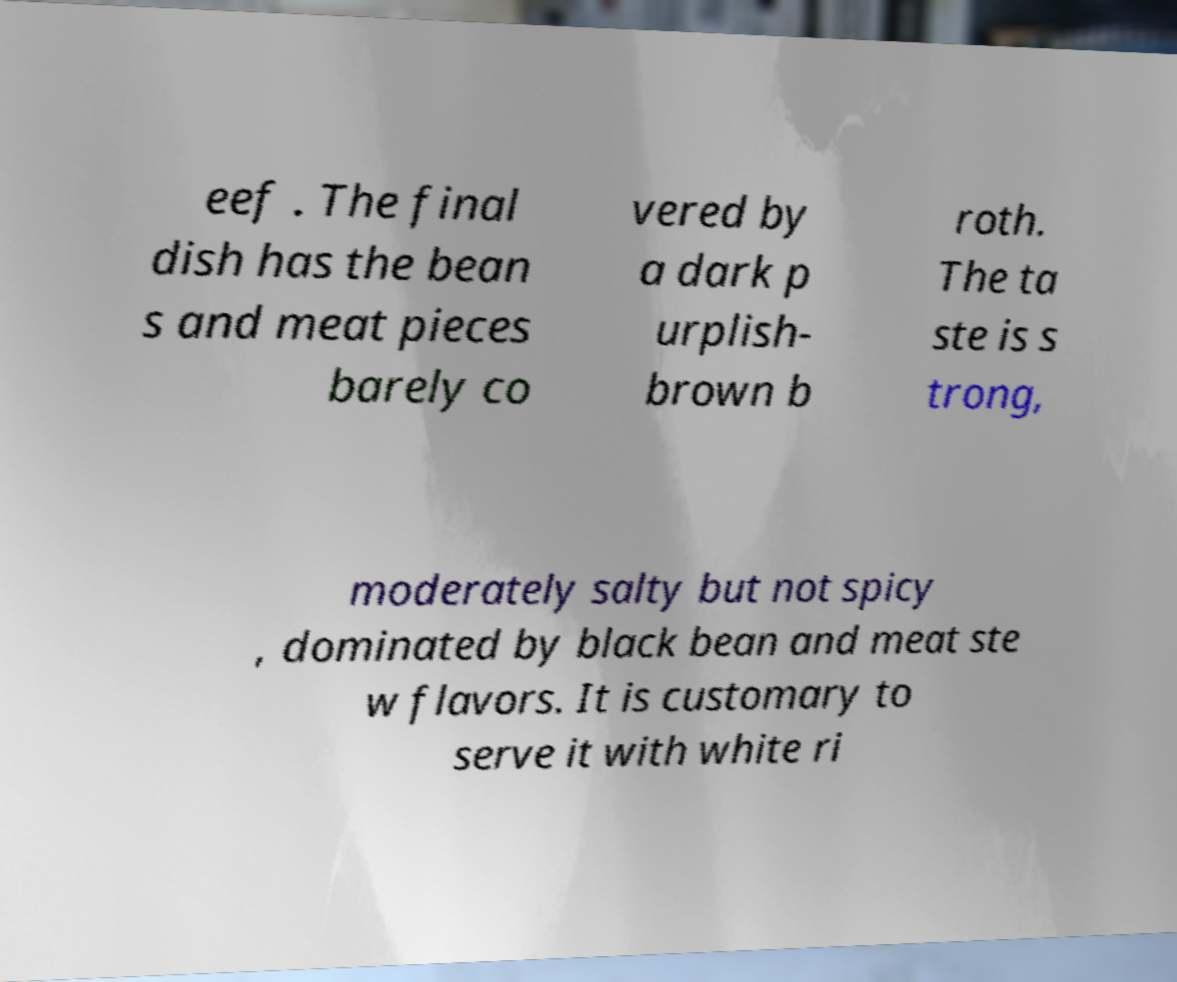Can you accurately transcribe the text from the provided image for me? eef . The final dish has the bean s and meat pieces barely co vered by a dark p urplish- brown b roth. The ta ste is s trong, moderately salty but not spicy , dominated by black bean and meat ste w flavors. It is customary to serve it with white ri 